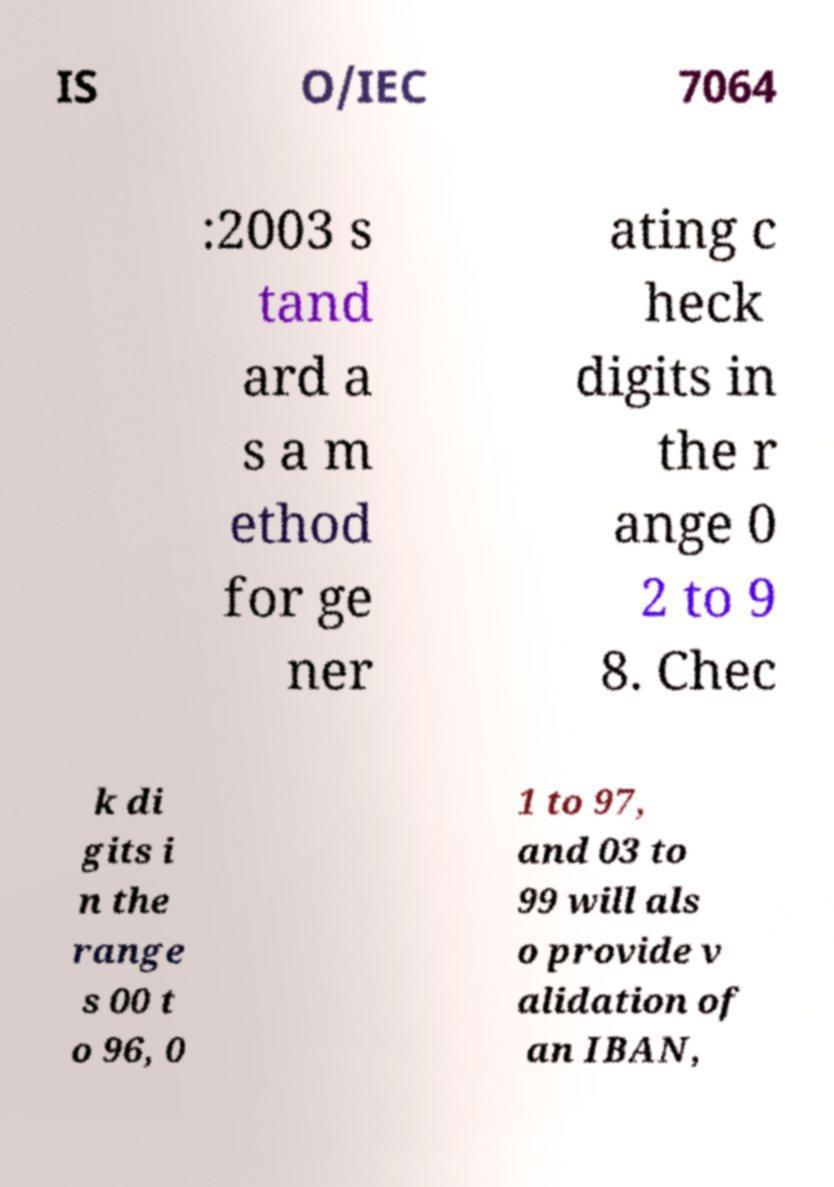Can you accurately transcribe the text from the provided image for me? IS O/IEC 7064 :2003 s tand ard a s a m ethod for ge ner ating c heck digits in the r ange 0 2 to 9 8. Chec k di gits i n the range s 00 t o 96, 0 1 to 97, and 03 to 99 will als o provide v alidation of an IBAN, 